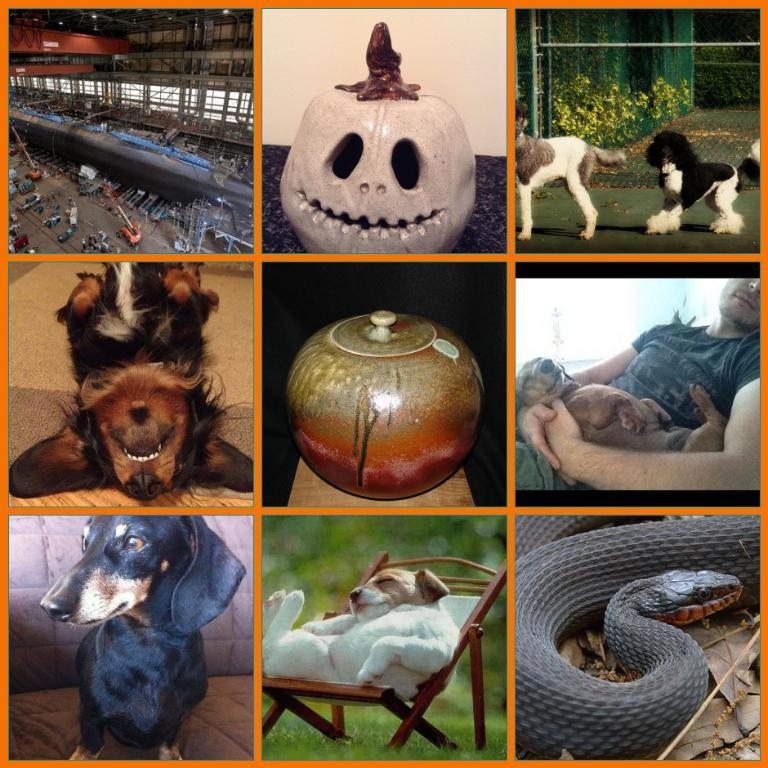What type of artwork is the image? The image is a collage. What types of living beings can be seen in the image? There are animals in the image. What non-living items are present in the image? There are objects in the image. Is there a person depicted in the image? Yes, there is a person in the image. What type of natural environment is visible in the image? There is grass in the image. What type of furniture is present in the image? There is a chair in the image. What theory is being proposed by the thread in the image? There is no thread present in the image, and therefore no theory can be proposed. 